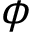Convert formula to latex. <formula><loc_0><loc_0><loc_500><loc_500>\phi</formula> 